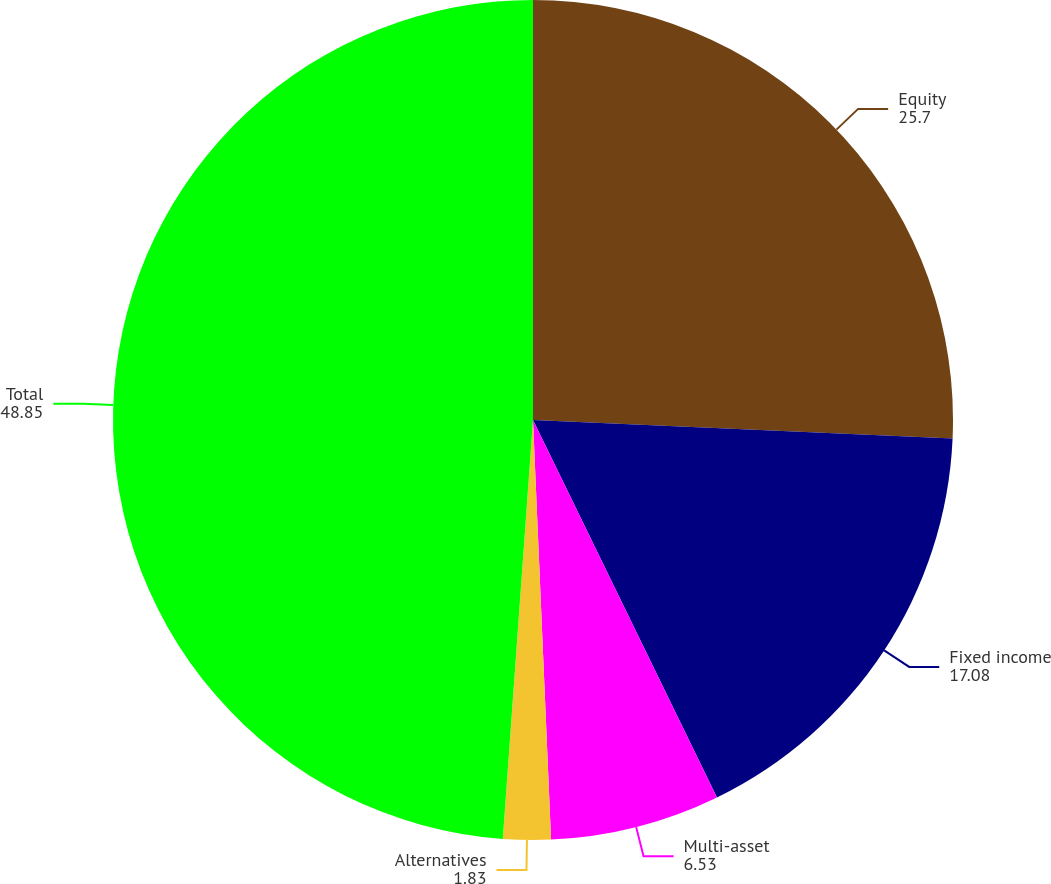Convert chart. <chart><loc_0><loc_0><loc_500><loc_500><pie_chart><fcel>Equity<fcel>Fixed income<fcel>Multi-asset<fcel>Alternatives<fcel>Total<nl><fcel>25.7%<fcel>17.08%<fcel>6.53%<fcel>1.83%<fcel>48.85%<nl></chart> 